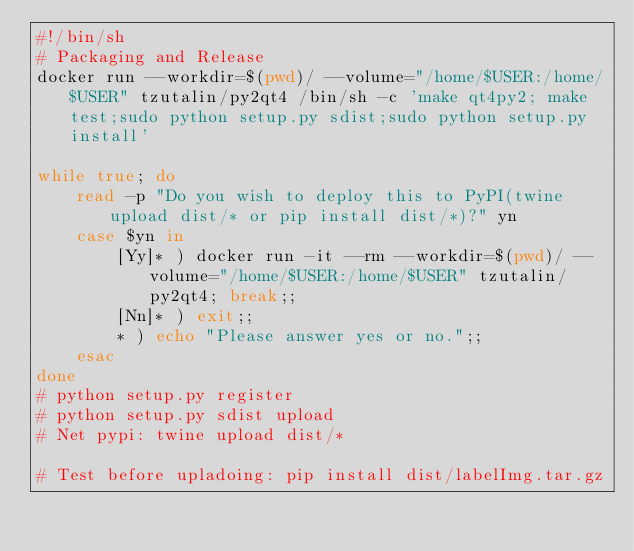<code> <loc_0><loc_0><loc_500><loc_500><_Bash_>#!/bin/sh
# Packaging and Release
docker run --workdir=$(pwd)/ --volume="/home/$USER:/home/$USER" tzutalin/py2qt4 /bin/sh -c 'make qt4py2; make test;sudo python setup.py sdist;sudo python setup.py install'

while true; do
    read -p "Do you wish to deploy this to PyPI(twine upload dist/* or pip install dist/*)?" yn
    case $yn in
        [Yy]* ) docker run -it --rm --workdir=$(pwd)/ --volume="/home/$USER:/home/$USER" tzutalin/py2qt4; break;;
        [Nn]* ) exit;;
        * ) echo "Please answer yes or no.";;
    esac
done
# python setup.py register
# python setup.py sdist upload
# Net pypi: twine upload dist/*

# Test before upladoing: pip install dist/labelImg.tar.gz
</code> 